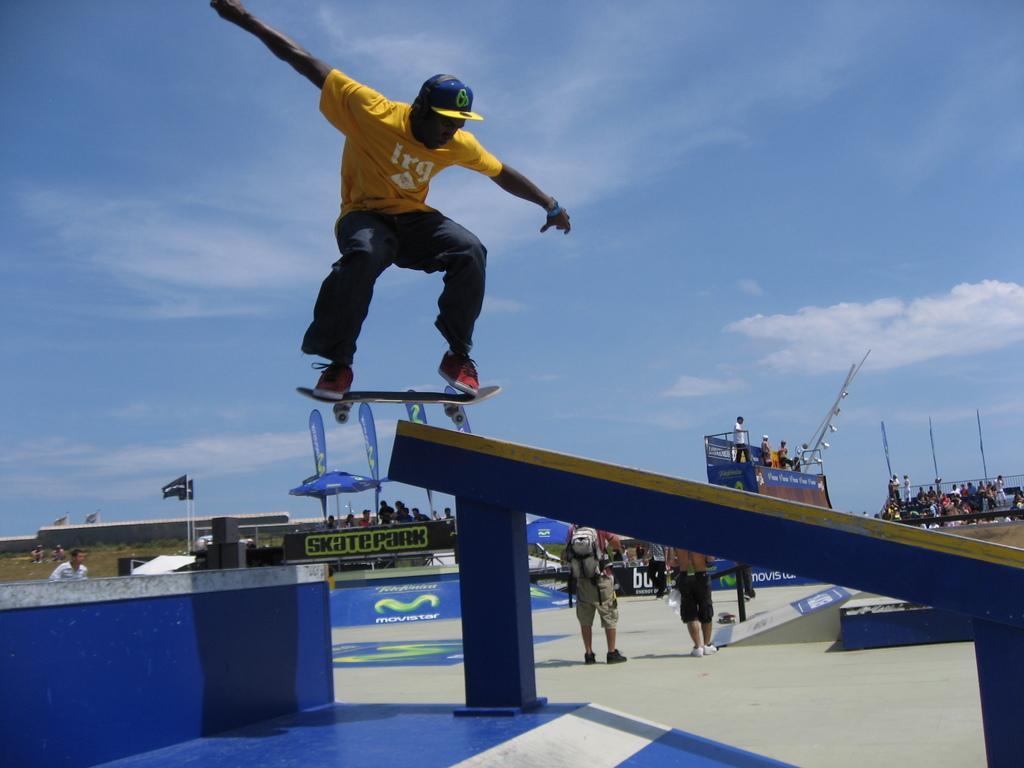Describe this image in one or two sentences. In this picture we can see a man standing on a skateboard and he is in the air. In the background we can see a group of people, two people are standing on the floor, banners, poles, flags, some objects and the sky. 